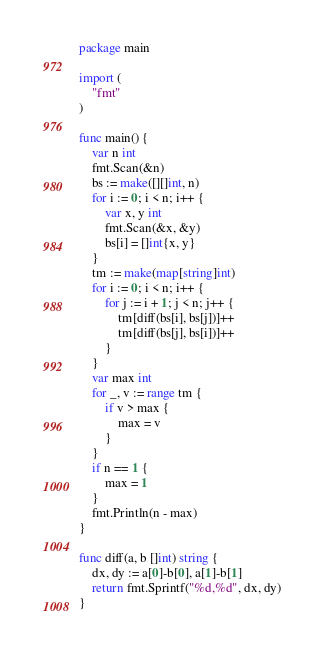Convert code to text. <code><loc_0><loc_0><loc_500><loc_500><_Go_>package main
  
import (
    "fmt"
)

func main() {
    var n int
    fmt.Scan(&n)
    bs := make([][]int, n)
    for i := 0; i < n; i++ {
        var x, y int
        fmt.Scan(&x, &y)
        bs[i] = []int{x, y}
    }
    tm := make(map[string]int)
    for i := 0; i < n; i++ {
        for j := i + 1; j < n; j++ {
            tm[diff(bs[i], bs[j])]++
            tm[diff(bs[j], bs[i])]++
        }
    }
    var max int
    for _, v := range tm {
        if v > max {
            max = v
        }
    }
    if n == 1 {
        max = 1
    }
    fmt.Println(n - max)
}

func diff(a, b []int) string {
    dx, dy := a[0]-b[0], a[1]-b[1]
    return fmt.Sprintf("%d,%d", dx, dy)
}
</code> 